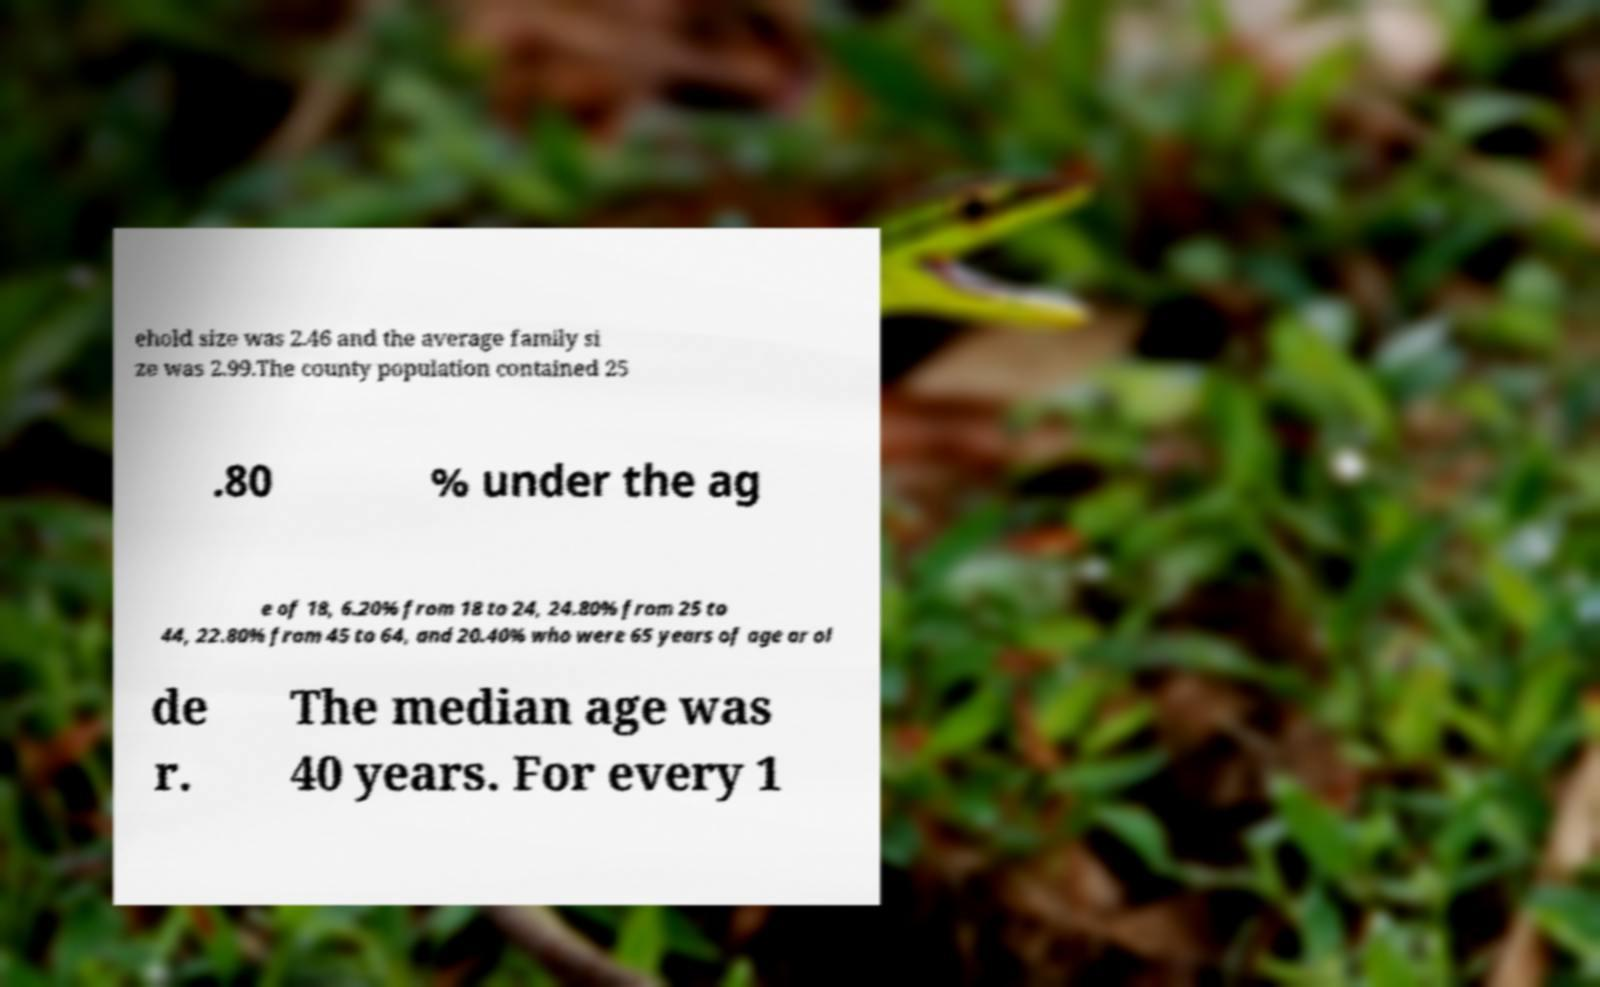I need the written content from this picture converted into text. Can you do that? ehold size was 2.46 and the average family si ze was 2.99.The county population contained 25 .80 % under the ag e of 18, 6.20% from 18 to 24, 24.80% from 25 to 44, 22.80% from 45 to 64, and 20.40% who were 65 years of age or ol de r. The median age was 40 years. For every 1 